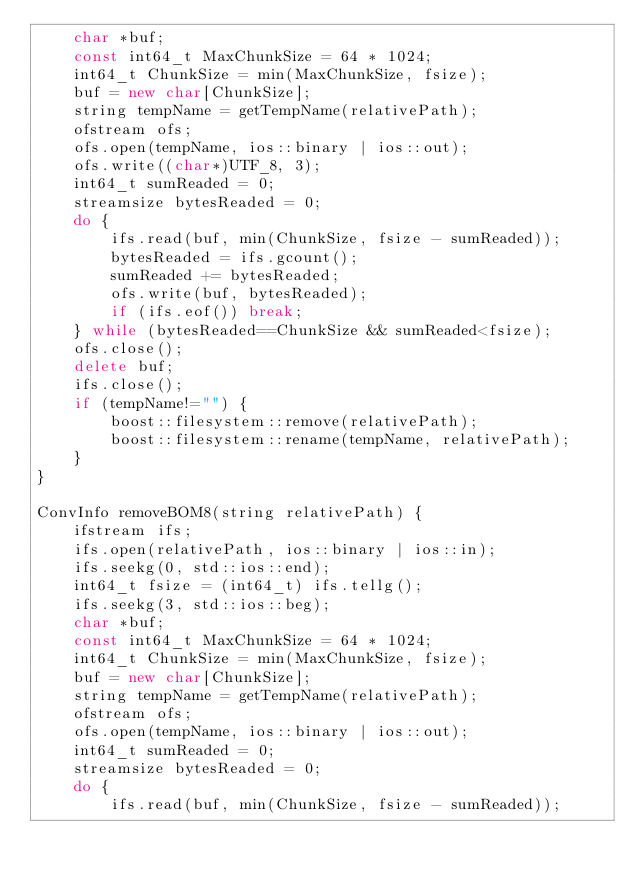<code> <loc_0><loc_0><loc_500><loc_500><_C++_>    char *buf;
    const int64_t MaxChunkSize = 64 * 1024;
    int64_t ChunkSize = min(MaxChunkSize, fsize);
    buf = new char[ChunkSize];
    string tempName = getTempName(relativePath);
    ofstream ofs;
    ofs.open(tempName, ios::binary | ios::out);
    ofs.write((char*)UTF_8, 3);
    int64_t sumReaded = 0;
    streamsize bytesReaded = 0;
    do {
        ifs.read(buf, min(ChunkSize, fsize - sumReaded));
        bytesReaded = ifs.gcount();
        sumReaded += bytesReaded;
        ofs.write(buf, bytesReaded);
        if (ifs.eof()) break;
    } while (bytesReaded==ChunkSize && sumReaded<fsize);
    ofs.close();
    delete buf;
    ifs.close();
    if (tempName!="") {
        boost::filesystem::remove(relativePath);
        boost::filesystem::rename(tempName, relativePath);
    }
}

ConvInfo removeBOM8(string relativePath) {
    ifstream ifs;
    ifs.open(relativePath, ios::binary | ios::in);
    ifs.seekg(0, std::ios::end);
    int64_t fsize = (int64_t) ifs.tellg();
    ifs.seekg(3, std::ios::beg);
    char *buf;
    const int64_t MaxChunkSize = 64 * 1024;
    int64_t ChunkSize = min(MaxChunkSize, fsize);
    buf = new char[ChunkSize];
    string tempName = getTempName(relativePath);
    ofstream ofs;
    ofs.open(tempName, ios::binary | ios::out);
    int64_t sumReaded = 0;
    streamsize bytesReaded = 0;
    do {
        ifs.read(buf, min(ChunkSize, fsize - sumReaded));</code> 